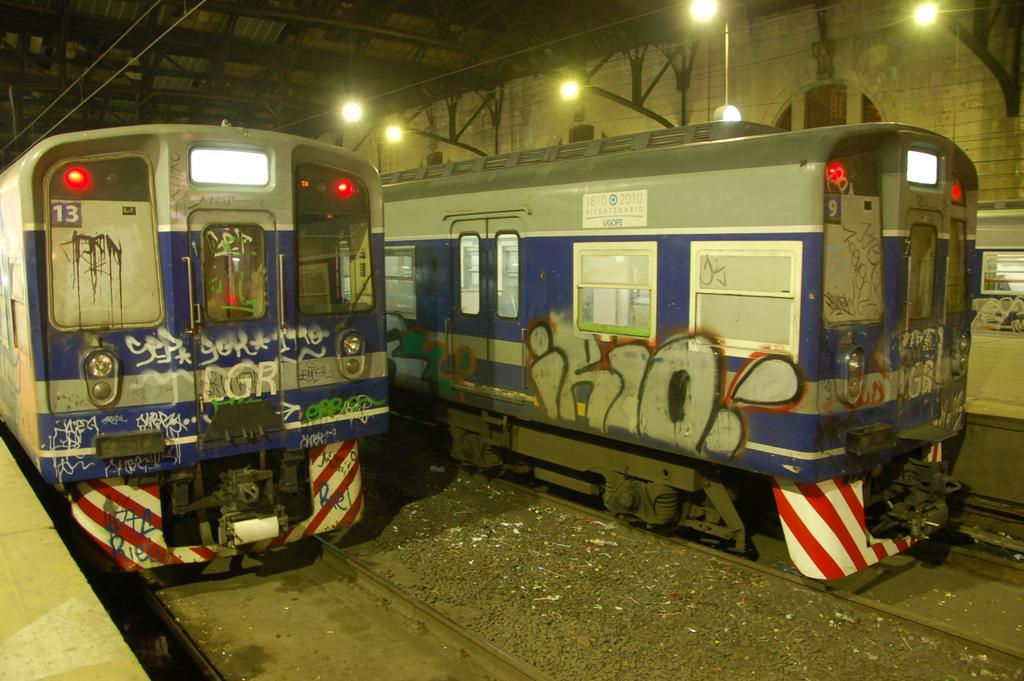What can be seen in the image? There are two trains in the image. How are the trains positioned in relation to each other? The trains are parked beside each other. What can be seen in the background of the image? There is a white color wall and a shed roof with lights in the background. What type of loaf is being advertised on the side of the train? There is no loaf or advertisement present on the side of the train in the image. What type of coil is used to power the lights on the shed roof? The image does not provide information about the type of coil used to power the lights on the shed roof. 